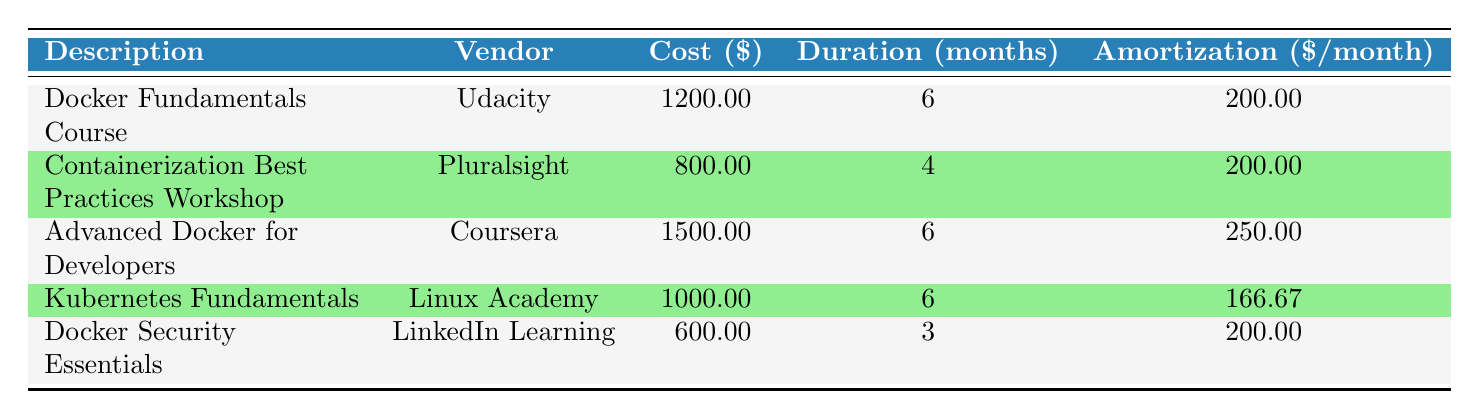What is the total cost of the Docker training courses from Udacity? The table shows that the cost of the "Docker Fundamentals Course" from Udacity is 1200. So, the total cost of this specific training is 1200.
Answer: 1200 Which course has the highest amortization per month? By comparing the amortization per month for each course, "Advanced Docker for Developers" has the highest value at 250.
Answer: Advanced Docker for Developers What is the total duration of training for all staff on Docker courses? To find the total duration, we add up the duration from all the courses: 6 + 4 + 6 + 6 + 3 = 25 months.
Answer: 25 months Is the "Kubernetes Fundamentals" course offered by Pluralsight? The table indicates that "Kubernetes Fundamentals" is provided by Linux Academy, not Pluralsight.
Answer: No What is the average amortization per month across all training courses? We sum the amortizations: 200 + 200 + 250 + 166.67 + 200 = 1016.67. Then, divide by the number of courses (5): 1016.67 / 5 = 203.33.
Answer: 203.33 How many training expenses have a cost of over 1000? Reviewing the costs, the courses over 1000 are: "Docker Fundamentals Course" (1200), "Advanced Docker for Developers" (1500), and "Kubernetes Fundamentals" (1000). This gives us a total of 3 training expenses.
Answer: 3 What is the total amortization value for the "Docker Security Essentials" course? The "Docker Security Essentials" course has an amortization of 200 per month over 3 months. Thus, the total amortization is 200 * 3 = 600.
Answer: 600 How many vendors are represented in the training table? The table lists 5 unique vendors corresponding to each training expense. They are Udacity, Pluralsight, Coursera, Linux Academy, and LinkedIn Learning.
Answer: 5 Which training course has the lowest cost, and what is that cost? By examining the costs, "Docker Security Essentials" at 600 is the lowest-cost course.
Answer: 600 